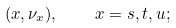Convert formula to latex. <formula><loc_0><loc_0><loc_500><loc_500>( x , { \nu } _ { x } ) , \quad x = s , t , u ;</formula> 